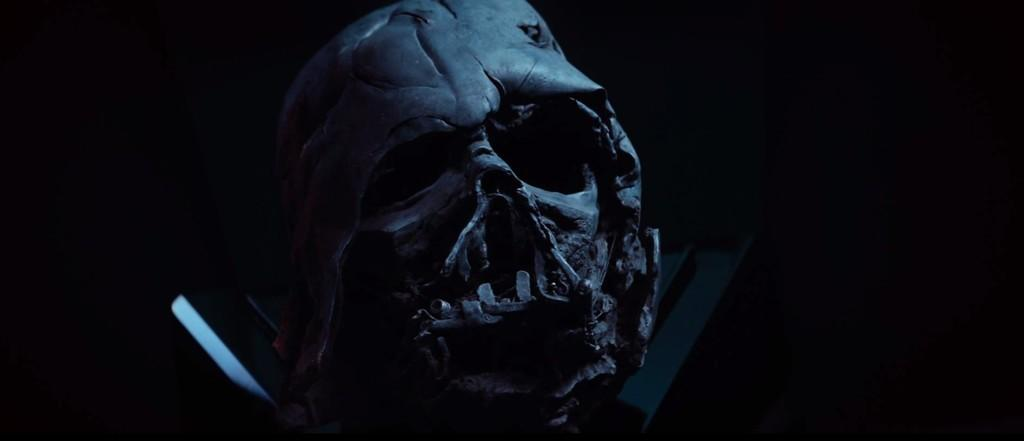What is the main subject of the image? There is a skull in the image. What can be observed about the background of the image? The background of the image is dark. What type of knee injury is depicted in the image? There is no knee injury present in the image; it features a skull. What kind of sail can be seen in the image? There is no sail present in the image; it only contains a skull and a dark background. 